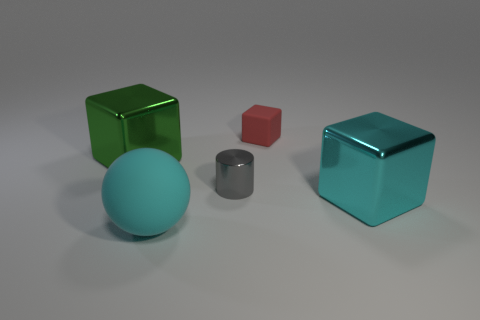Imagine these objects are characters in a story. What personalities might they have? In a narrative, the green cube could embody a vibrant and energetic character, always on the move. The red cube might be its smaller, feisty sidekick. The gray cylinder could represent the wise foil to their excitement, grounded and calm. The teal cube, with its shiny exterior, could be seen as a mysterious, enigmatic figure with hidden depths. 